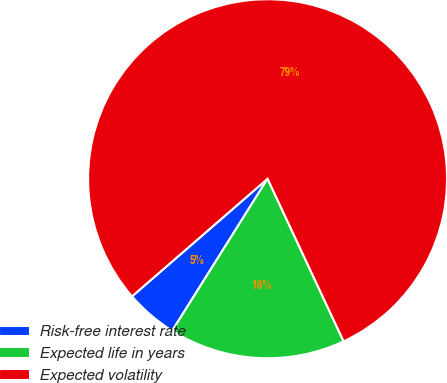Convert chart to OTSL. <chart><loc_0><loc_0><loc_500><loc_500><pie_chart><fcel>Risk-free interest rate<fcel>Expected life in years<fcel>Expected volatility<nl><fcel>4.71%<fcel>15.88%<fcel>79.41%<nl></chart> 